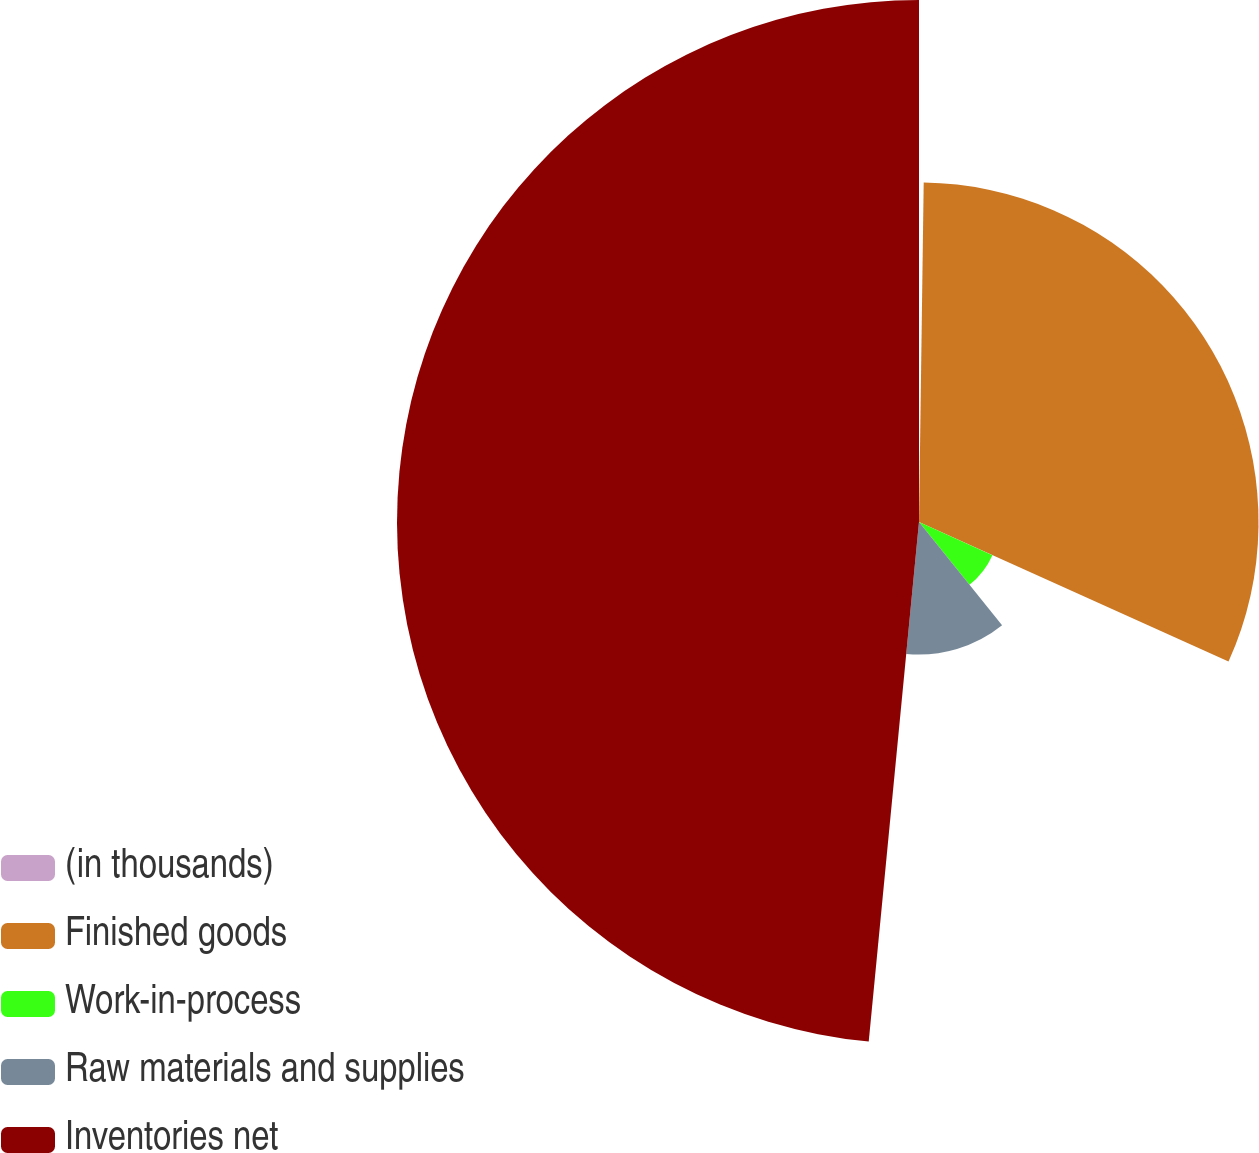<chart> <loc_0><loc_0><loc_500><loc_500><pie_chart><fcel>(in thousands)<fcel>Finished goods<fcel>Work-in-process<fcel>Raw materials and supplies<fcel>Inventories net<nl><fcel>0.22%<fcel>31.52%<fcel>7.48%<fcel>12.31%<fcel>48.46%<nl></chart> 